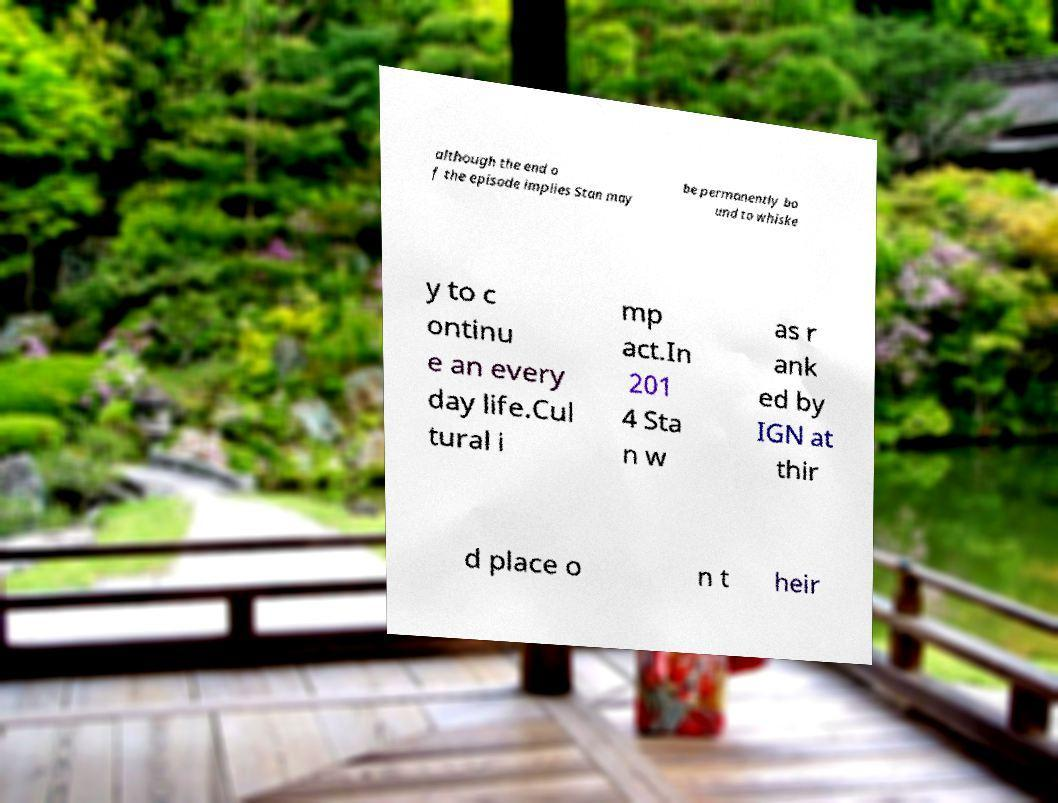There's text embedded in this image that I need extracted. Can you transcribe it verbatim? although the end o f the episode implies Stan may be permanently bo und to whiske y to c ontinu e an every day life.Cul tural i mp act.In 201 4 Sta n w as r ank ed by IGN at thir d place o n t heir 